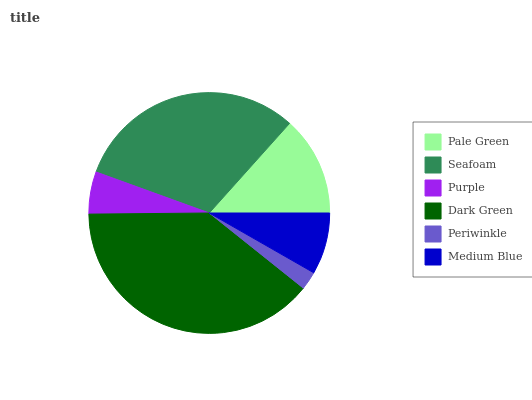Is Periwinkle the minimum?
Answer yes or no. Yes. Is Dark Green the maximum?
Answer yes or no. Yes. Is Seafoam the minimum?
Answer yes or no. No. Is Seafoam the maximum?
Answer yes or no. No. Is Seafoam greater than Pale Green?
Answer yes or no. Yes. Is Pale Green less than Seafoam?
Answer yes or no. Yes. Is Pale Green greater than Seafoam?
Answer yes or no. No. Is Seafoam less than Pale Green?
Answer yes or no. No. Is Pale Green the high median?
Answer yes or no. Yes. Is Medium Blue the low median?
Answer yes or no. Yes. Is Periwinkle the high median?
Answer yes or no. No. Is Purple the low median?
Answer yes or no. No. 